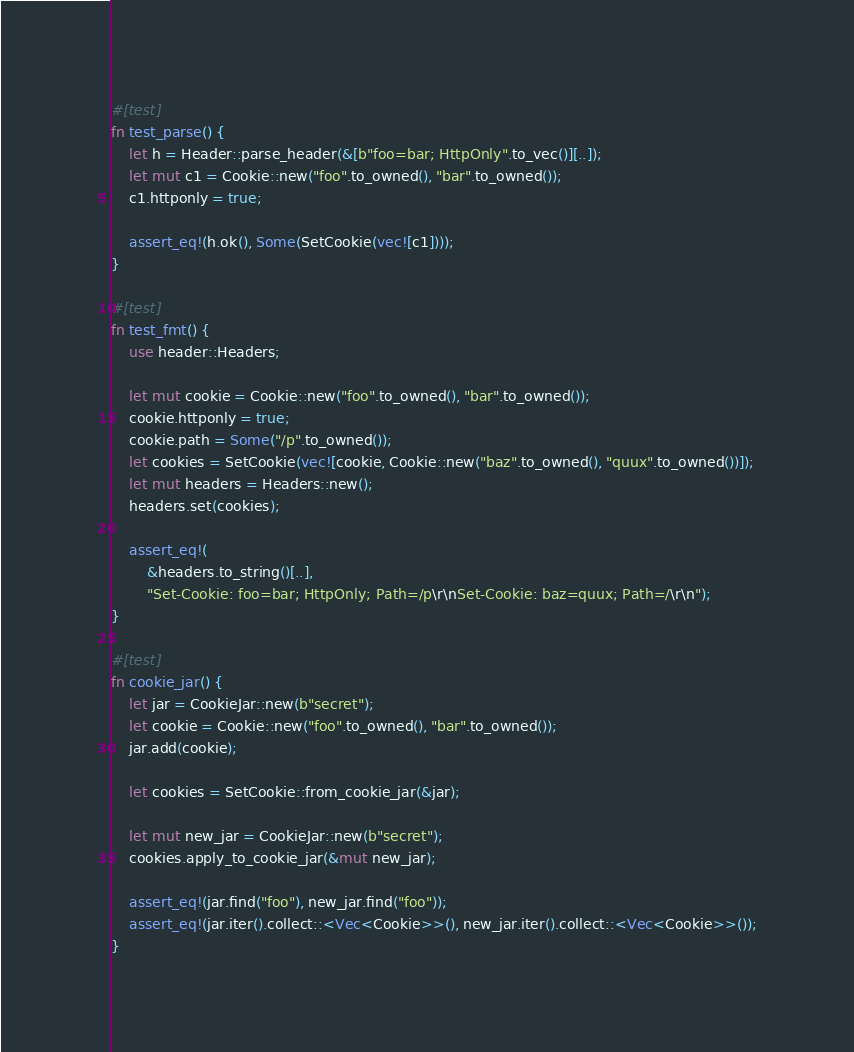<code> <loc_0><loc_0><loc_500><loc_500><_Rust_>

#[test]
fn test_parse() {
    let h = Header::parse_header(&[b"foo=bar; HttpOnly".to_vec()][..]);
    let mut c1 = Cookie::new("foo".to_owned(), "bar".to_owned());
    c1.httponly = true;

    assert_eq!(h.ok(), Some(SetCookie(vec![c1])));
}

#[test]
fn test_fmt() {
    use header::Headers;

    let mut cookie = Cookie::new("foo".to_owned(), "bar".to_owned());
    cookie.httponly = true;
    cookie.path = Some("/p".to_owned());
    let cookies = SetCookie(vec![cookie, Cookie::new("baz".to_owned(), "quux".to_owned())]);
    let mut headers = Headers::new();
    headers.set(cookies);

    assert_eq!(
        &headers.to_string()[..],
        "Set-Cookie: foo=bar; HttpOnly; Path=/p\r\nSet-Cookie: baz=quux; Path=/\r\n");
}

#[test]
fn cookie_jar() {
    let jar = CookieJar::new(b"secret");
    let cookie = Cookie::new("foo".to_owned(), "bar".to_owned());
    jar.add(cookie);

    let cookies = SetCookie::from_cookie_jar(&jar);

    let mut new_jar = CookieJar::new(b"secret");
    cookies.apply_to_cookie_jar(&mut new_jar);

    assert_eq!(jar.find("foo"), new_jar.find("foo"));
    assert_eq!(jar.iter().collect::<Vec<Cookie>>(), new_jar.iter().collect::<Vec<Cookie>>());
}
</code> 